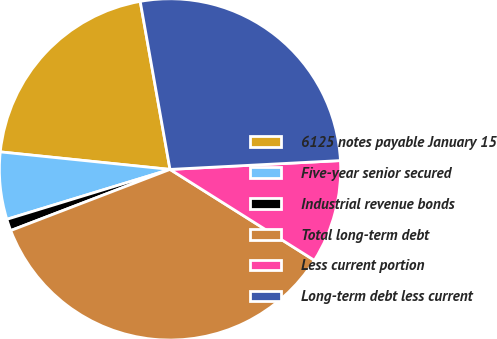Convert chart to OTSL. <chart><loc_0><loc_0><loc_500><loc_500><pie_chart><fcel>6125 notes payable January 15<fcel>Five-year senior secured<fcel>Industrial revenue bonds<fcel>Total long-term debt<fcel>Less current portion<fcel>Long-term debt less current<nl><fcel>20.57%<fcel>6.36%<fcel>1.11%<fcel>35.22%<fcel>9.77%<fcel>26.97%<nl></chart> 